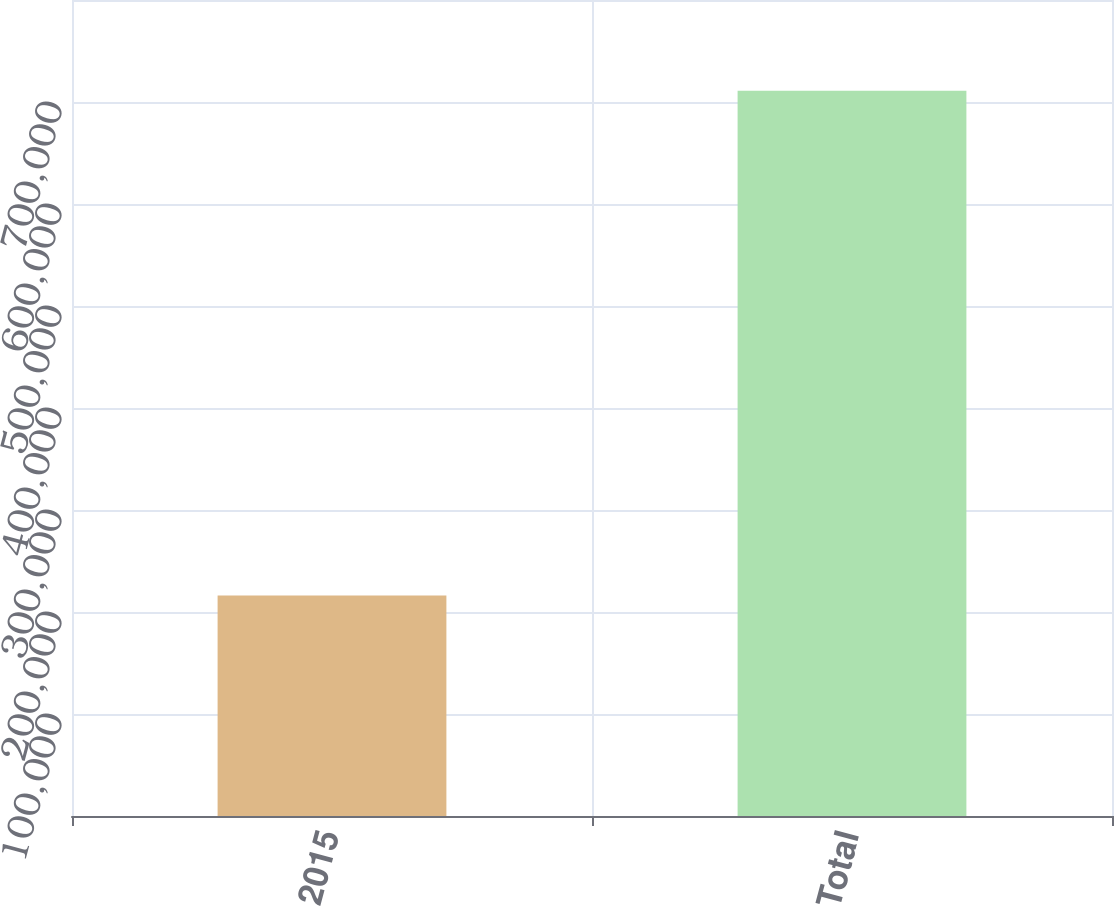Convert chart. <chart><loc_0><loc_0><loc_500><loc_500><bar_chart><fcel>2015<fcel>Total<nl><fcel>216216<fcel>711097<nl></chart> 